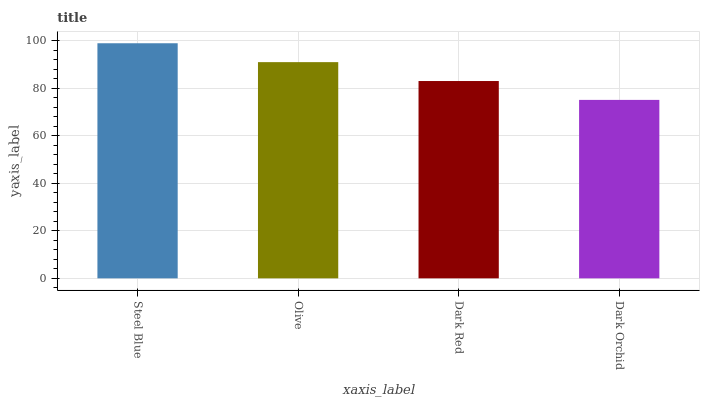Is Dark Orchid the minimum?
Answer yes or no. Yes. Is Steel Blue the maximum?
Answer yes or no. Yes. Is Olive the minimum?
Answer yes or no. No. Is Olive the maximum?
Answer yes or no. No. Is Steel Blue greater than Olive?
Answer yes or no. Yes. Is Olive less than Steel Blue?
Answer yes or no. Yes. Is Olive greater than Steel Blue?
Answer yes or no. No. Is Steel Blue less than Olive?
Answer yes or no. No. Is Olive the high median?
Answer yes or no. Yes. Is Dark Red the low median?
Answer yes or no. Yes. Is Dark Orchid the high median?
Answer yes or no. No. Is Dark Orchid the low median?
Answer yes or no. No. 